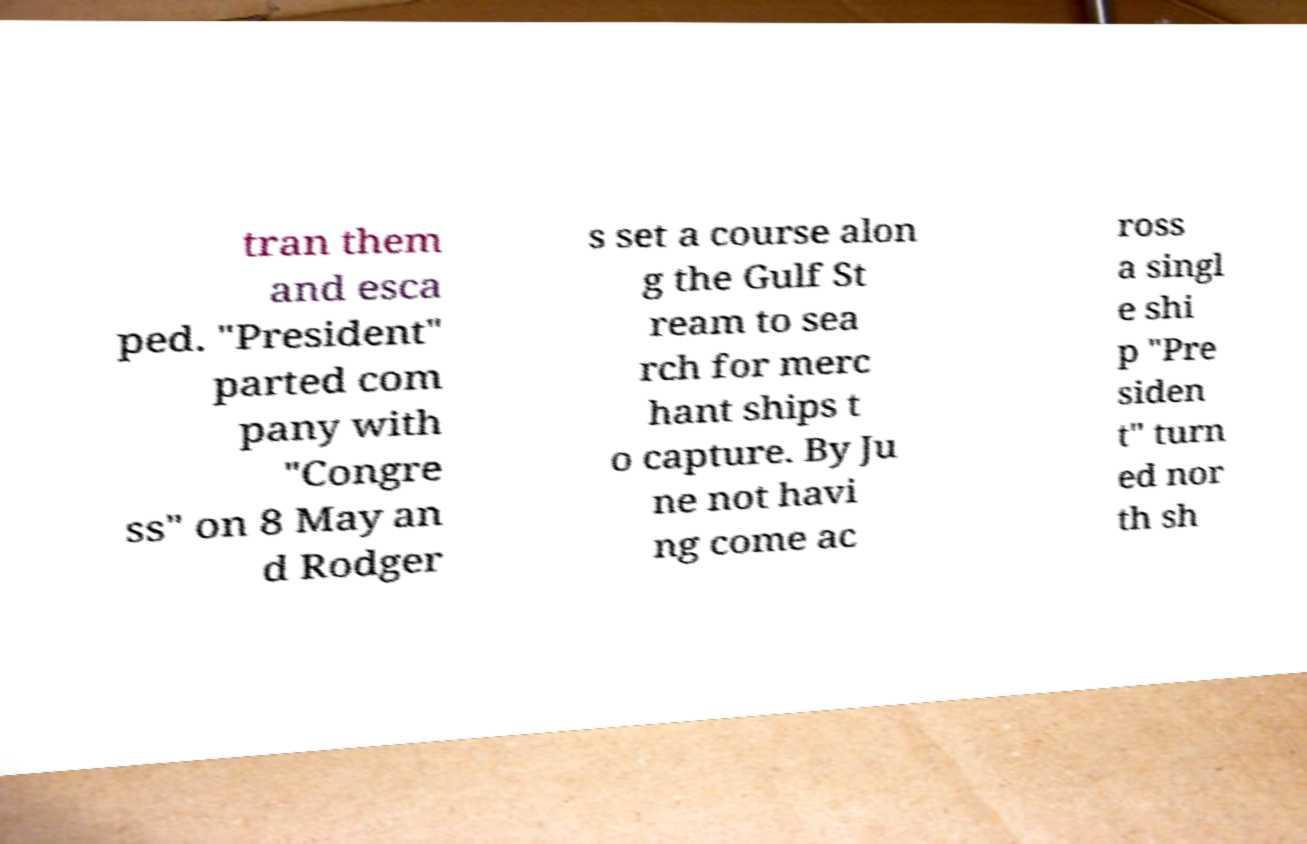Please read and relay the text visible in this image. What does it say? tran them and esca ped. "President" parted com pany with "Congre ss" on 8 May an d Rodger s set a course alon g the Gulf St ream to sea rch for merc hant ships t o capture. By Ju ne not havi ng come ac ross a singl e shi p "Pre siden t" turn ed nor th sh 